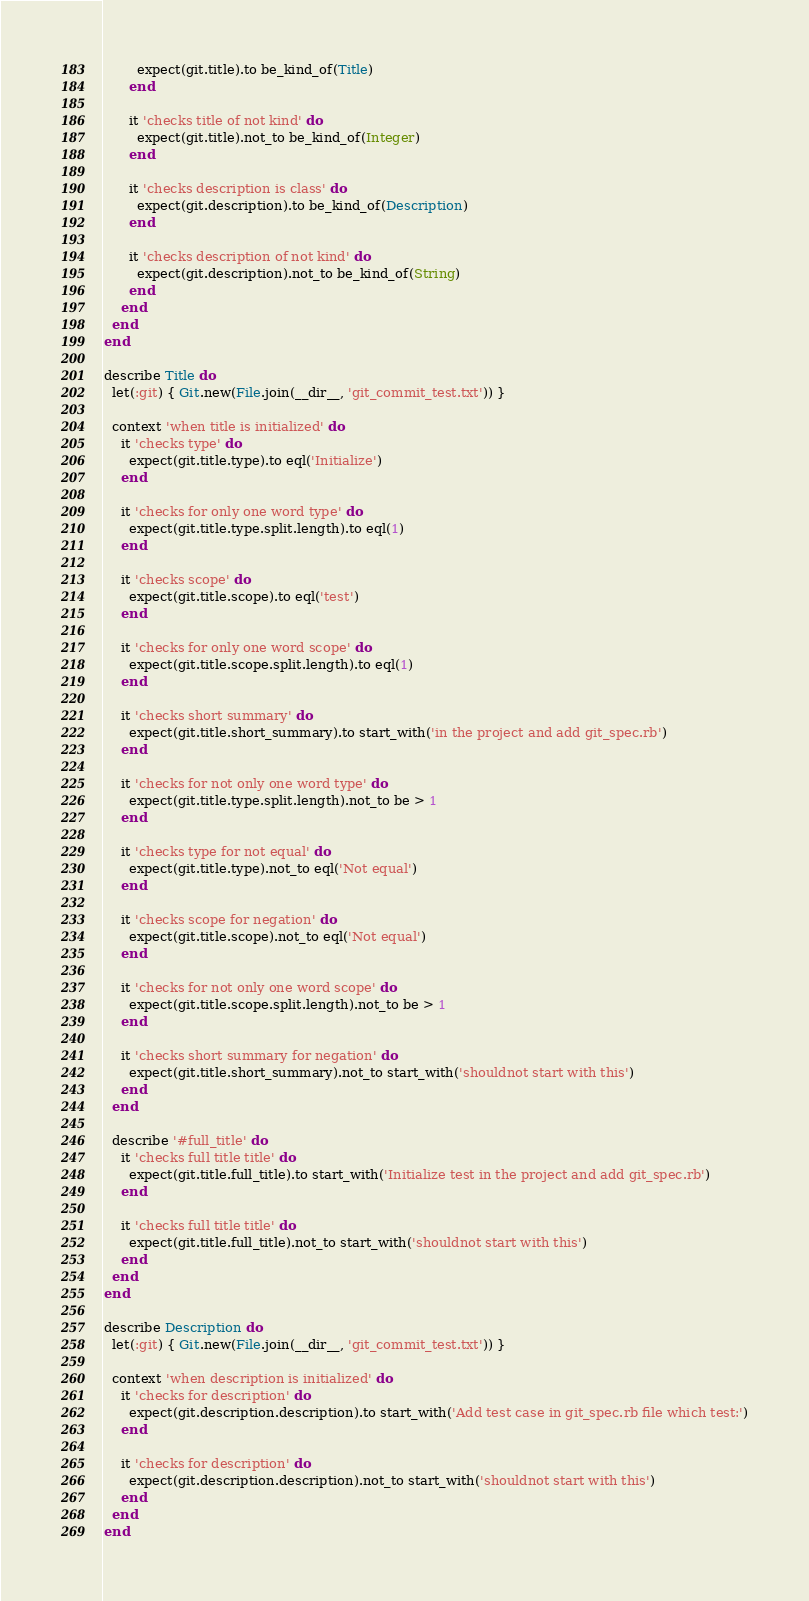Convert code to text. <code><loc_0><loc_0><loc_500><loc_500><_Ruby_>        expect(git.title).to be_kind_of(Title)
      end

      it 'checks title of not kind' do
        expect(git.title).not_to be_kind_of(Integer)
      end

      it 'checks description is class' do
        expect(git.description).to be_kind_of(Description)
      end

      it 'checks description of not kind' do
        expect(git.description).not_to be_kind_of(String)
      end
    end
  end
end

describe Title do
  let(:git) { Git.new(File.join(__dir__, 'git_commit_test.txt')) }

  context 'when title is initialized' do
    it 'checks type' do
      expect(git.title.type).to eql('Initialize')
    end

    it 'checks for only one word type' do
      expect(git.title.type.split.length).to eql(1)
    end

    it 'checks scope' do
      expect(git.title.scope).to eql('test')
    end

    it 'checks for only one word scope' do
      expect(git.title.scope.split.length).to eql(1)
    end

    it 'checks short summary' do
      expect(git.title.short_summary).to start_with('in the project and add git_spec.rb')
    end

    it 'checks for not only one word type' do
      expect(git.title.type.split.length).not_to be > 1
    end

    it 'checks type for not equal' do
      expect(git.title.type).not_to eql('Not equal')
    end

    it 'checks scope for negation' do
      expect(git.title.scope).not_to eql('Not equal')
    end

    it 'checks for not only one word scope' do
      expect(git.title.scope.split.length).not_to be > 1
    end

    it 'checks short summary for negation' do
      expect(git.title.short_summary).not_to start_with('shouldnot start with this')
    end
  end

  describe '#full_title' do
    it 'checks full title title' do
      expect(git.title.full_title).to start_with('Initialize test in the project and add git_spec.rb')
    end

    it 'checks full title title' do
      expect(git.title.full_title).not_to start_with('shouldnot start with this')
    end
  end
end

describe Description do
  let(:git) { Git.new(File.join(__dir__, 'git_commit_test.txt')) }

  context 'when description is initialized' do
    it 'checks for description' do
      expect(git.description.description).to start_with('Add test case in git_spec.rb file which test:')
    end

    it 'checks for description' do
      expect(git.description.description).not_to start_with('shouldnot start with this')
    end
  end
end
</code> 